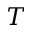<formula> <loc_0><loc_0><loc_500><loc_500>T</formula> 